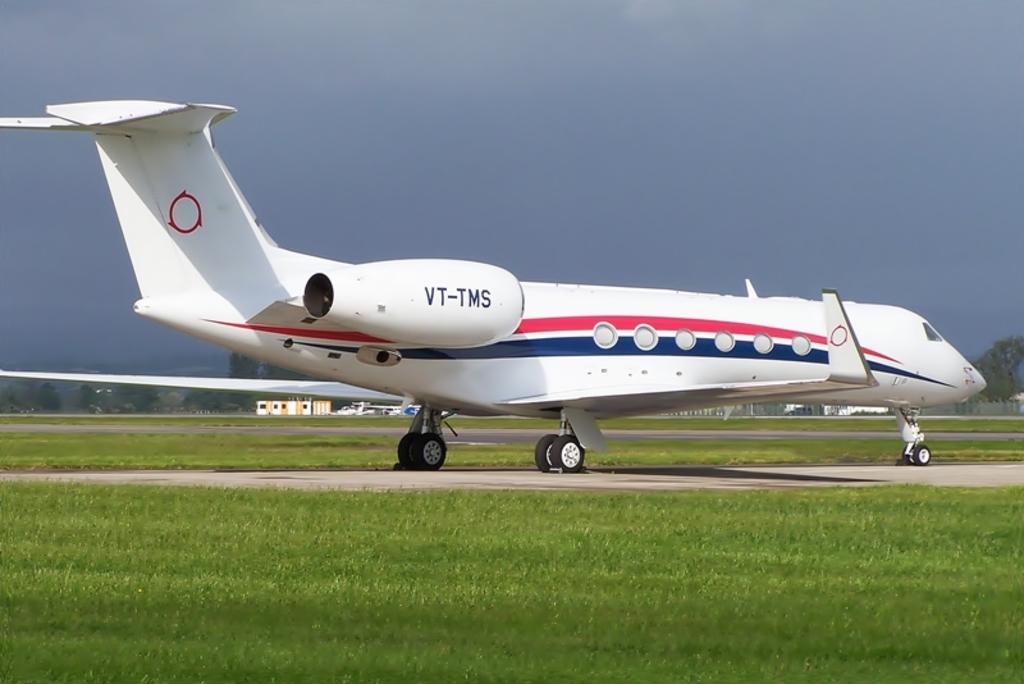What is the plane name?
Give a very brief answer. Vt-tms. What's the number listed on this plane?
Ensure brevity in your answer.  Vt-tms. 